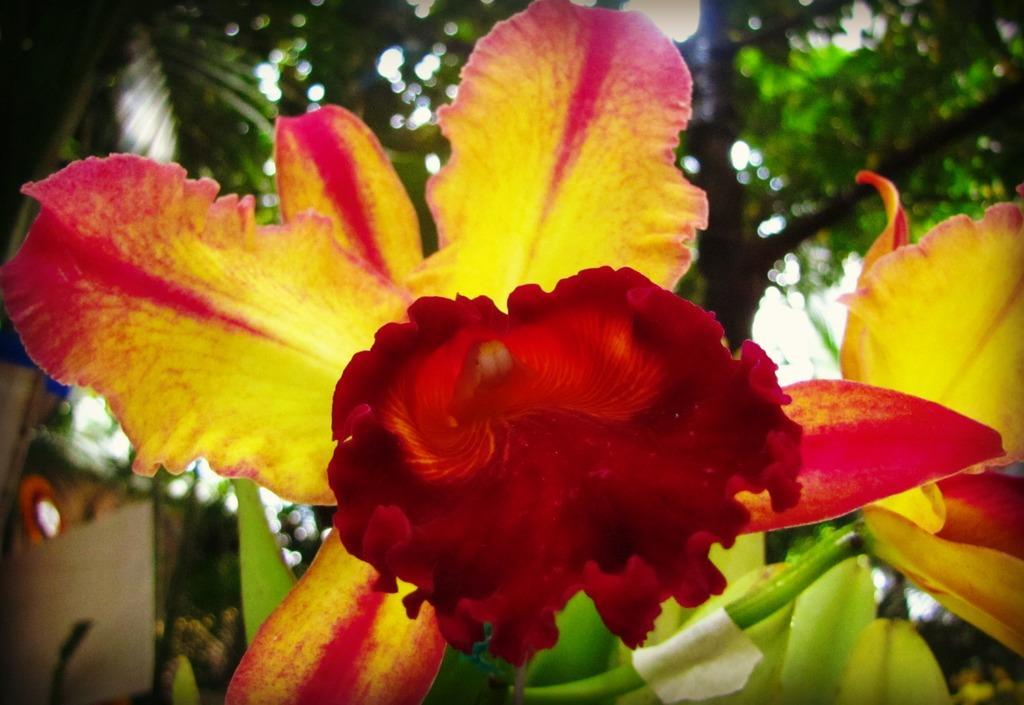What type of plant is present in the image? There is a plant with yellowish red color flowers in the image. What can be seen in the background of the image? There are trees in the background of the image. How many frogs can be seen playing with plastic toys in the image? There are no frogs or plastic toys present in the image. 